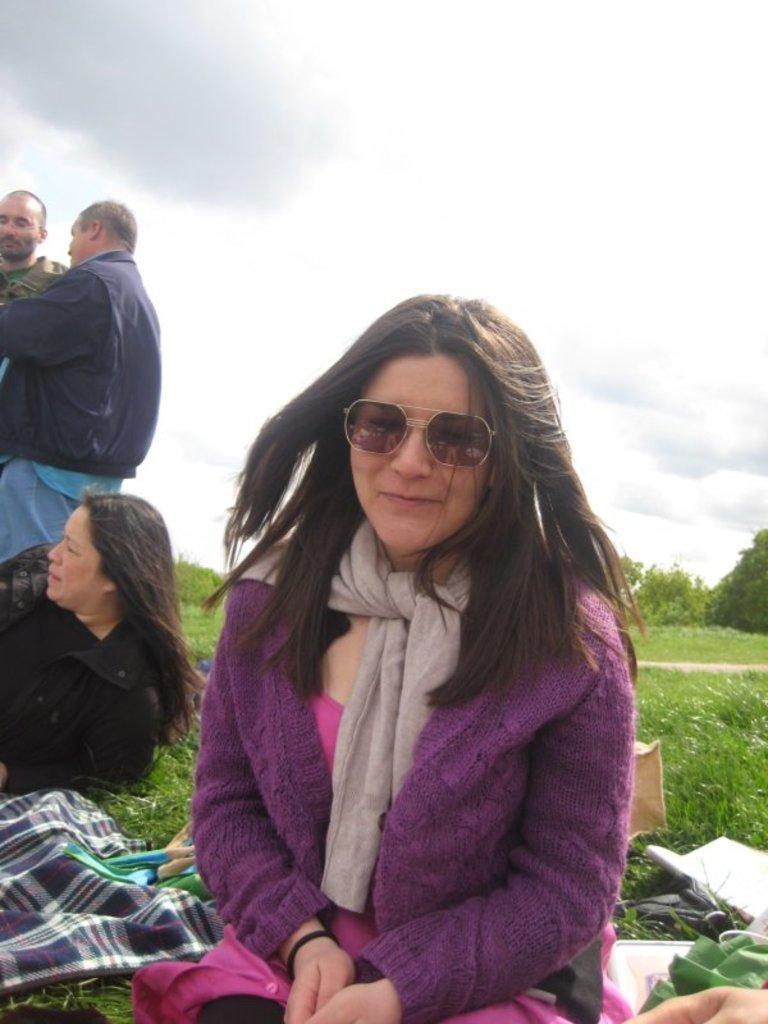Describe this image in one or two sentences. In this image I can see an open grass ground and on it I can see two women and two men. I can see all of them are wearing jackets. I can also see few clothes and few other things on the ground. In the front of the image I can see one woman is wearing a brown shades. In the background I can see number of trees, clouds and the sky. 